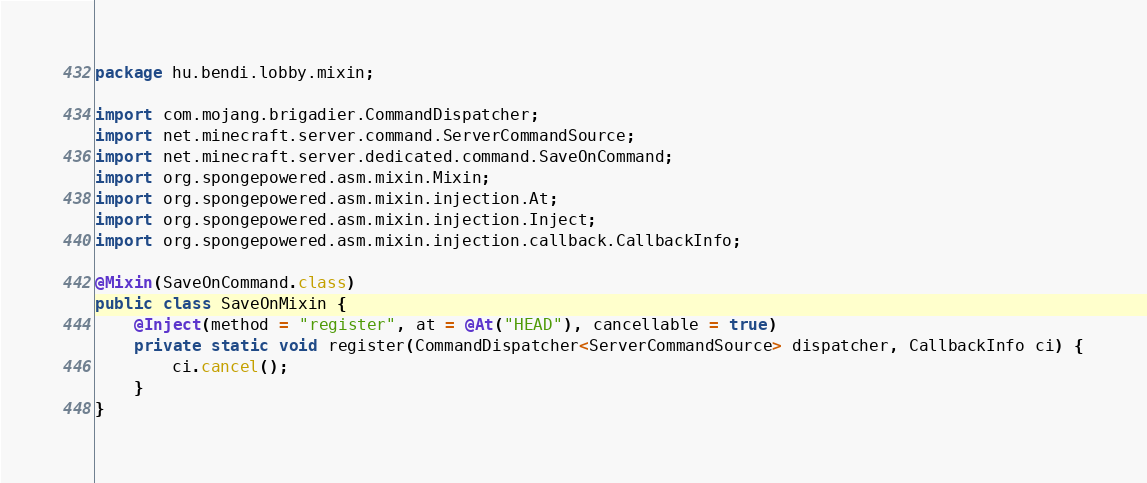Convert code to text. <code><loc_0><loc_0><loc_500><loc_500><_Java_>package hu.bendi.lobby.mixin;

import com.mojang.brigadier.CommandDispatcher;
import net.minecraft.server.command.ServerCommandSource;
import net.minecraft.server.dedicated.command.SaveOnCommand;
import org.spongepowered.asm.mixin.Mixin;
import org.spongepowered.asm.mixin.injection.At;
import org.spongepowered.asm.mixin.injection.Inject;
import org.spongepowered.asm.mixin.injection.callback.CallbackInfo;

@Mixin(SaveOnCommand.class)
public class SaveOnMixin {
    @Inject(method = "register", at = @At("HEAD"), cancellable = true)
    private static void register(CommandDispatcher<ServerCommandSource> dispatcher, CallbackInfo ci) {
        ci.cancel();
    }
}
</code> 